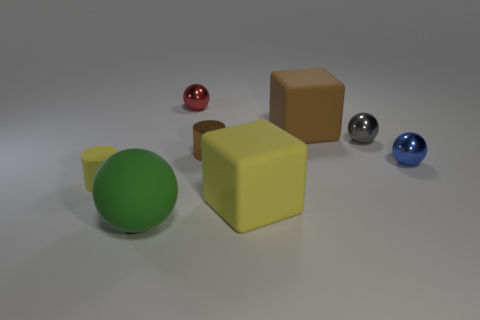If these objects were part of a children's toy set, what might be missing from the set based on what you see? Considering the objects as part of a children's toy set, it lacks a variety of shapes to make it more engaging. Including additional geometric shapes like a pyramid, cone, or cylinder could enhance the set for educational purposes such as teaching about different volumes and surface areas. 